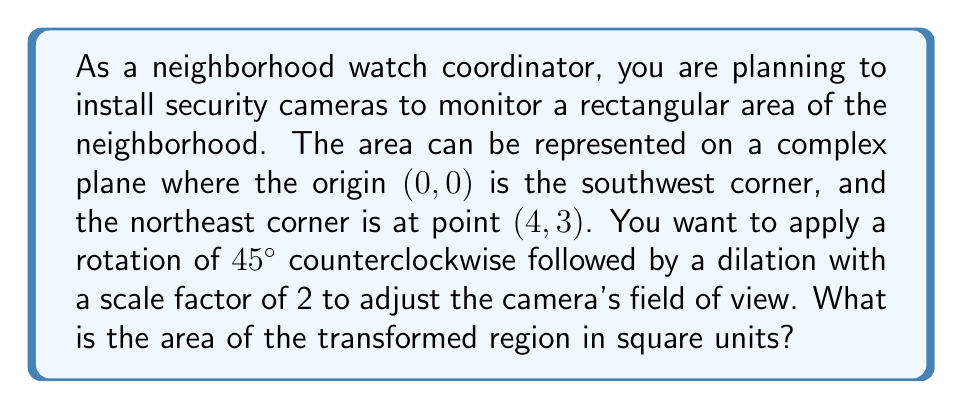Help me with this question. Let's approach this step-by-step:

1) First, we need to identify the complex numbers representing the corners of the original rectangle:
   Southwest: $0 + 0i$
   Southeast: $4 + 0i$
   Northwest: $0 + 3i$
   Northeast: $4 + 3i$

2) The rotation of 45° counterclockwise can be represented by multiplication with $\frac{1}{\sqrt{2}}(1+i)$. The dilation by a factor of 2 is simply multiplication by 2.

3) We can combine these transformations into a single complex number:
   $2 \cdot \frac{1}{\sqrt{2}}(1+i) = \sqrt{2}(1+i)$

4) Now, let's apply this transformation to each corner:

   Southwest: $0 \rightarrow 0$
   Southeast: $4 + 0i \rightarrow 4\sqrt{2}(1+i) = 4\sqrt{2} + 4\sqrt{2}i$
   Northwest: $3i \rightarrow 3\sqrt{2}(-1+i) = -3\sqrt{2} + 3\sqrt{2}i$
   Northeast: $4 + 3i \rightarrow (4+3i)\sqrt{2}(1+i) = (4\sqrt{2}-3\sqrt{2}) + (4\sqrt{2}+3\sqrt{2})i = \sqrt{2} + 7\sqrt{2}i$

5) The transformed rectangle is now a parallelogram. To find its area, we can use the formula:
   Area = $|Re(z_1)\cdot Im(z_2) - Re(z_2)\cdot Im(z_1)|$
   where $z_1$ and $z_2$ are any two adjacent sides of the parallelogram.

6) Let's choose the sides from 0 to $4\sqrt{2} + 4\sqrt{2}i$ and from 0 to $-3\sqrt{2} + 3\sqrt{2}i$:

   $z_1 = 4\sqrt{2} + 4\sqrt{2}i$
   $z_2 = -3\sqrt{2} + 3\sqrt{2}i$

7) Applying the formula:
   Area = $|(4\sqrt{2})(3\sqrt{2}) - (-3\sqrt{2})(4\sqrt{2})|$
        = $|12 + 12| = 24$

Therefore, the area of the transformed region is 24 square units.
Answer: 24 square units 